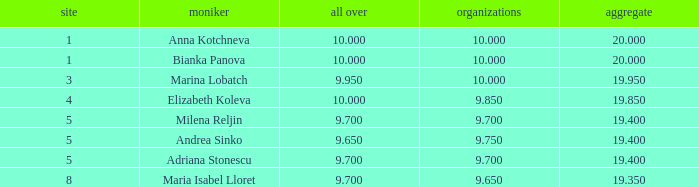What total has 10 as the clubs, with a place greater than 1? 19.95. 